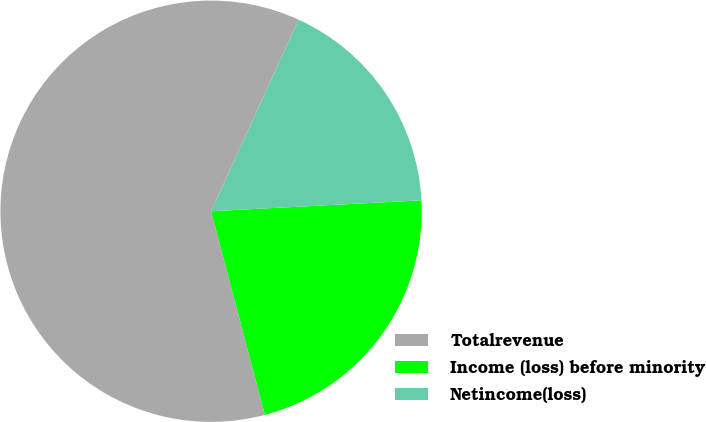Convert chart. <chart><loc_0><loc_0><loc_500><loc_500><pie_chart><fcel>Totalrevenue<fcel>Income (loss) before minority<fcel>Netincome(loss)<nl><fcel>60.93%<fcel>21.71%<fcel>17.35%<nl></chart> 